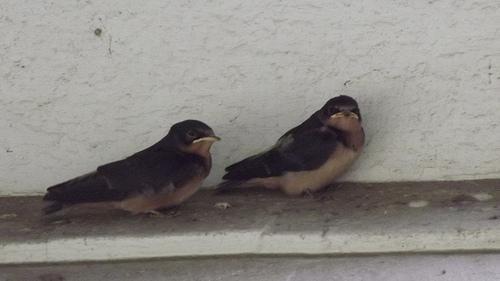How many animals are there?
Give a very brief answer. 2. 